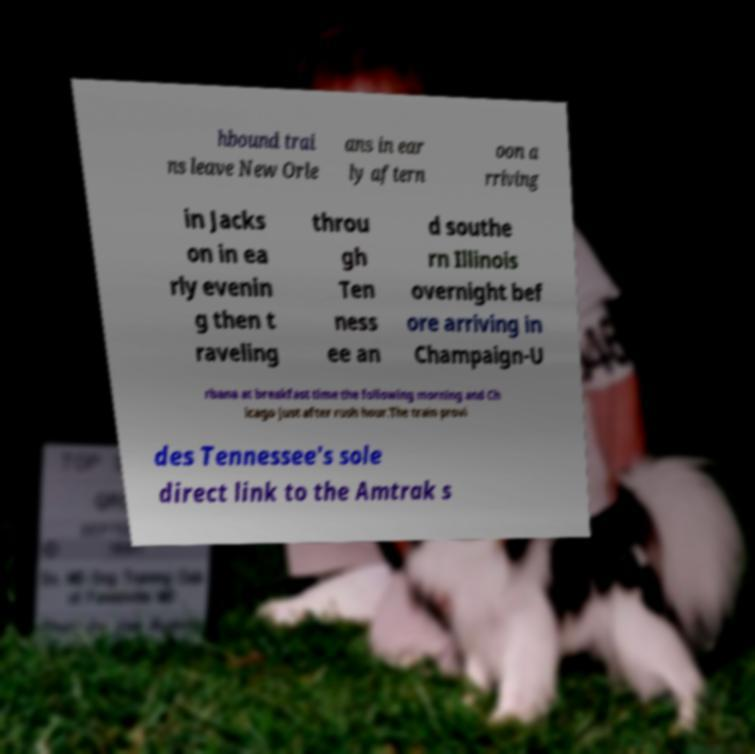Could you extract and type out the text from this image? hbound trai ns leave New Orle ans in ear ly aftern oon a rriving in Jacks on in ea rly evenin g then t raveling throu gh Ten ness ee an d southe rn Illinois overnight bef ore arriving in Champaign-U rbana at breakfast time the following morning and Ch icago just after rush hour.The train provi des Tennessee's sole direct link to the Amtrak s 